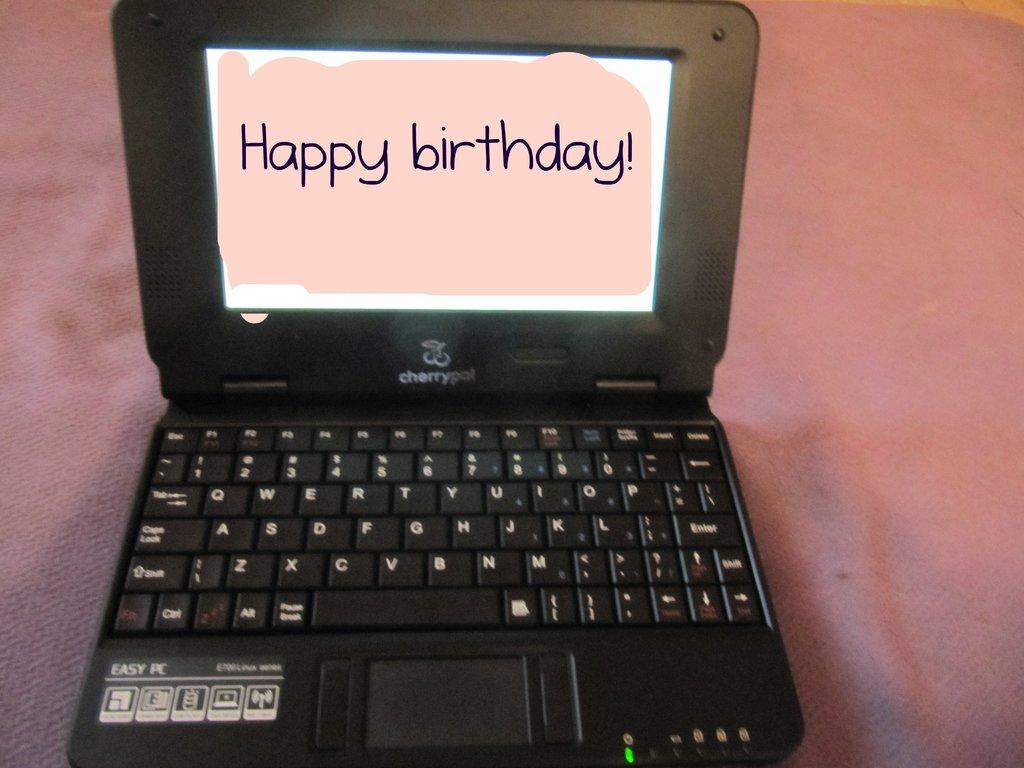<image>
Share a concise interpretation of the image provided. A cherrypal Easy PC is sitting on a pink fabric with the words Happy Birthday on the screen. 